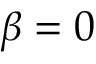Convert formula to latex. <formula><loc_0><loc_0><loc_500><loc_500>\beta = 0</formula> 